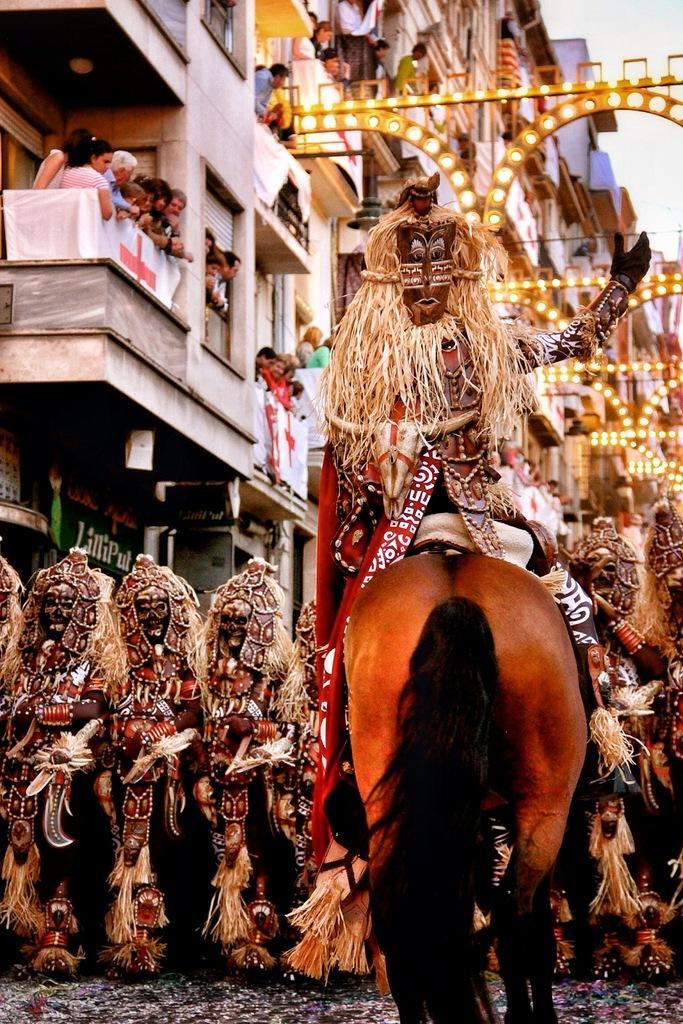Could you give a brief overview of what you see in this image? In this picture we can see a person is sitting on a horse. In front of the person there are some people in the fancy dresses and some people are standing in the balconies. Behind the people there are some decorative lights, buildings and the sky. 